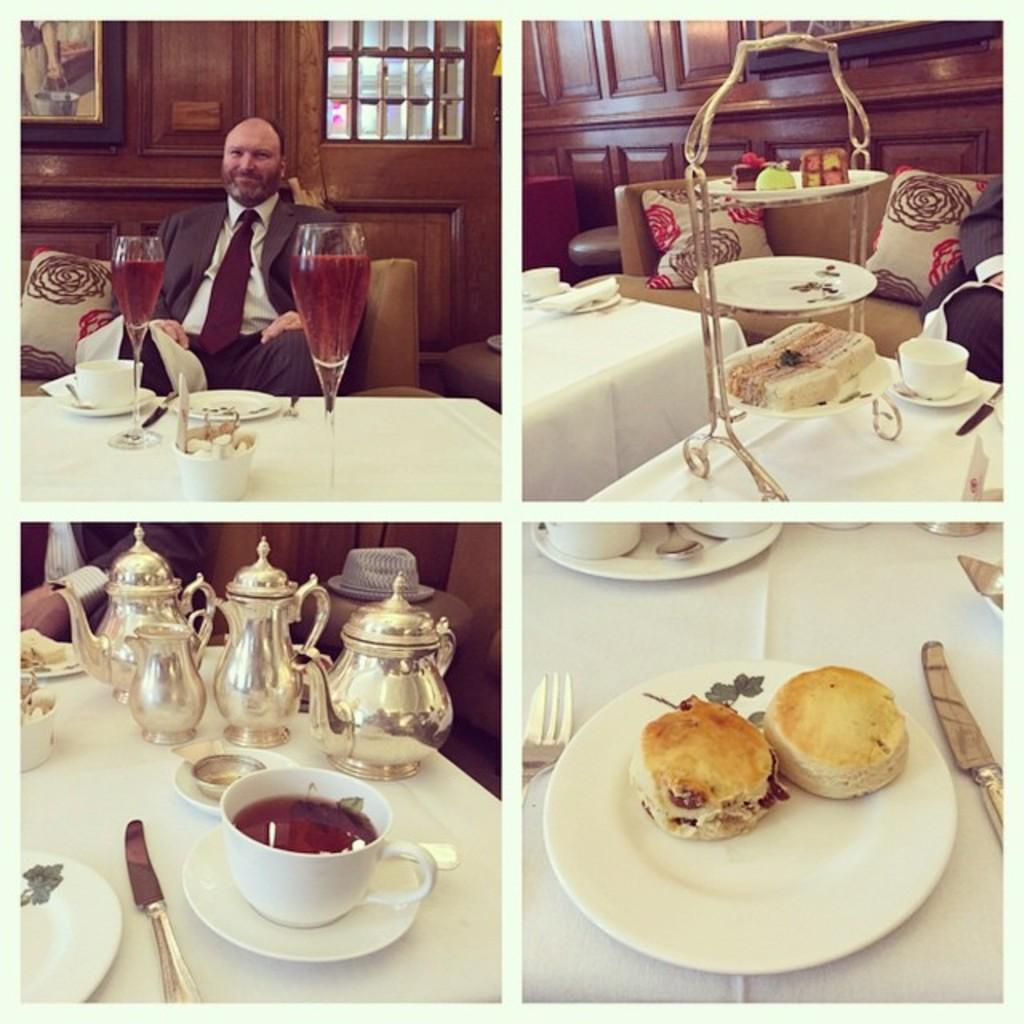What is the man in the image doing? The man is sitting on a couch in the image. What objects are on the table in the image? There are two glasses on a table in the image. What type of food can be seen in the image? There is a plate of food in the image. Can you describe the background of the image? In the background, there is a wooden wall, a window, and a knife visible. Is the farmer stuck in quicksand outside the window in the image? There is no farmer or quicksand present in the image. What type of cord is connected to the knife in the image? There is no cord connected to the knife in the image; it is simply visible in the background. 